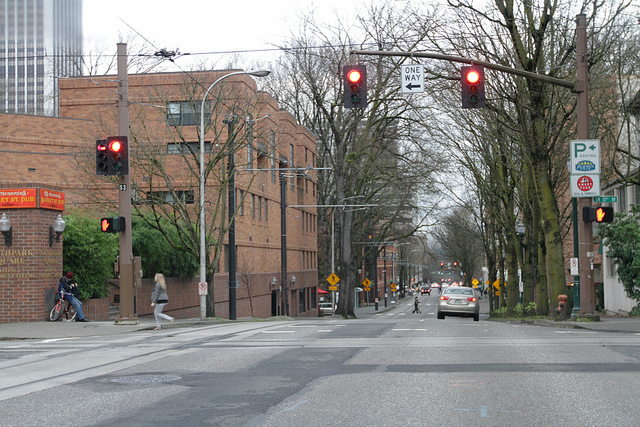Read and extract the text from this image. ONE WAY P 8 H 